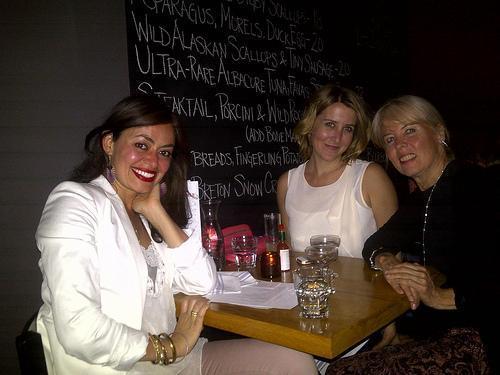How many people are there?
Give a very brief answer. 3. How many people are wearing white?
Give a very brief answer. 2. 